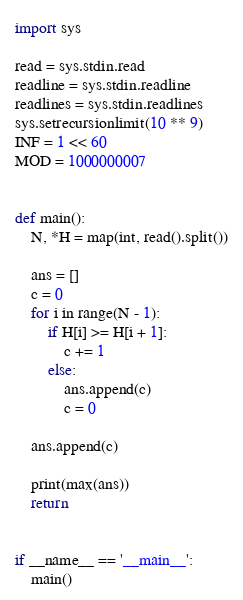Convert code to text. <code><loc_0><loc_0><loc_500><loc_500><_Python_>import sys

read = sys.stdin.read
readline = sys.stdin.readline
readlines = sys.stdin.readlines
sys.setrecursionlimit(10 ** 9)
INF = 1 << 60
MOD = 1000000007


def main():
    N, *H = map(int, read().split())

    ans = []
    c = 0
    for i in range(N - 1):
        if H[i] >= H[i + 1]:
            c += 1
        else:
            ans.append(c)
            c = 0

    ans.append(c)

    print(max(ans))
    return


if __name__ == '__main__':
    main()
</code> 